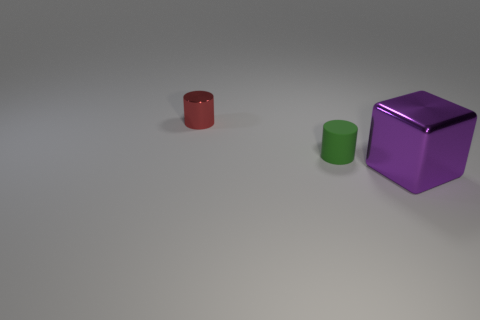Is there any other thing that is the same size as the block?
Your answer should be compact. No. Is there any other thing that is made of the same material as the green cylinder?
Keep it short and to the point. No. How big is the thing that is left of the rubber cylinder?
Your response must be concise. Small. Is the number of big shiny objects left of the tiny red cylinder less than the number of things that are behind the green cylinder?
Your answer should be compact. Yes. The matte object is what color?
Your answer should be very brief. Green. There is a tiny object that is in front of the tiny cylinder that is on the left side of the cylinder that is in front of the tiny red shiny object; what shape is it?
Ensure brevity in your answer.  Cylinder. There is a small thing in front of the red shiny object; what is it made of?
Your answer should be very brief. Rubber. What size is the cylinder on the right side of the metal object to the left of the thing that is in front of the green rubber cylinder?
Make the answer very short. Small. Do the green thing and the object on the left side of the rubber object have the same size?
Keep it short and to the point. Yes. What is the color of the tiny object on the left side of the tiny green cylinder?
Provide a succinct answer. Red. 